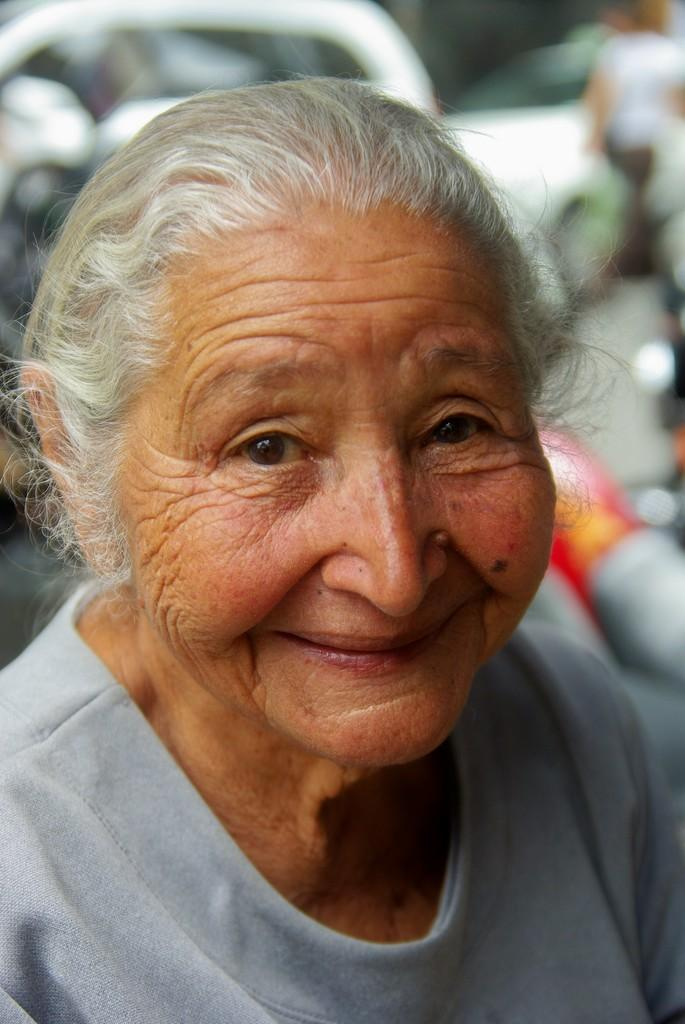Who is the main subject in the image? There is an old lady in the image. What is the old lady wearing? The old lady is wearing a grey t-shirt. What is the old lady's expression in the image? The old lady is smiling. What can be seen in the background of the image? There are vehicles moving on the road in the background of the image. How would you describe the background of the image? The background is blurred. What verse is the old lady reciting in the image? There is no indication in the image that the old lady is reciting a verse. What rule is the old lady enforcing in the image? There is no indication in the image that the old lady is enforcing any rules. 